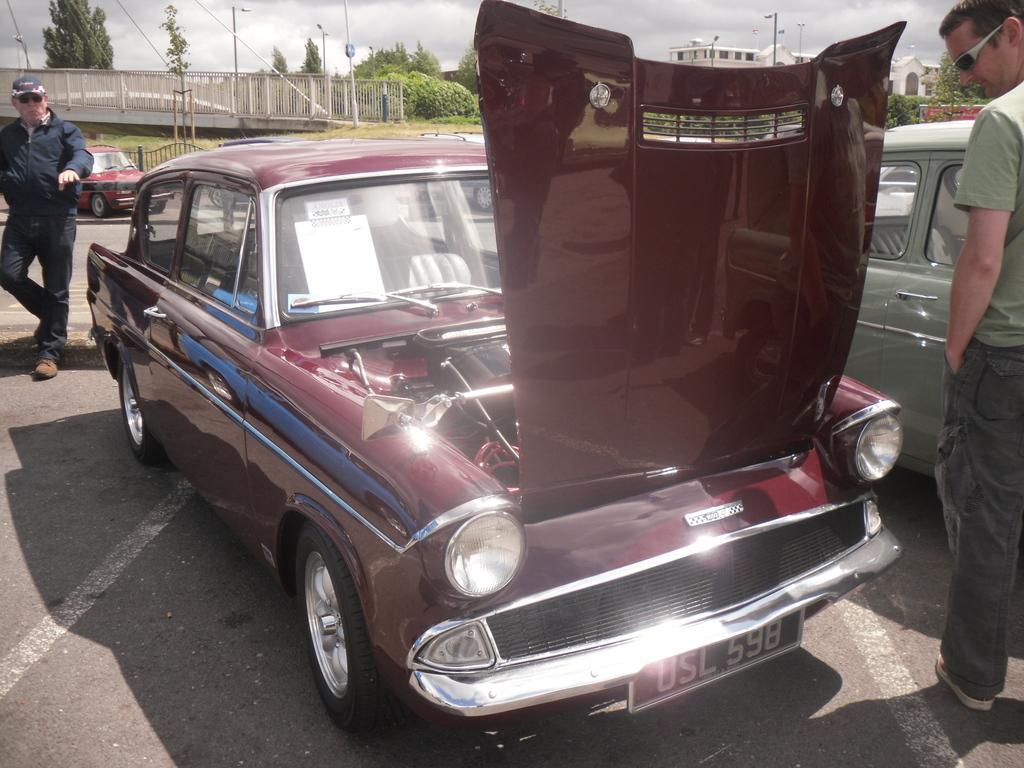Could you give a brief overview of what you see in this image? In this image I can see few vehicle, in front the vehicle is in maroon color. I can also see two persons, the person at right wearing green shirt, gray pant and the person at left wearing black color dress. Background I can see a bridge, few buildings in white color, light poles, trees in green color and the sky is in white color. 